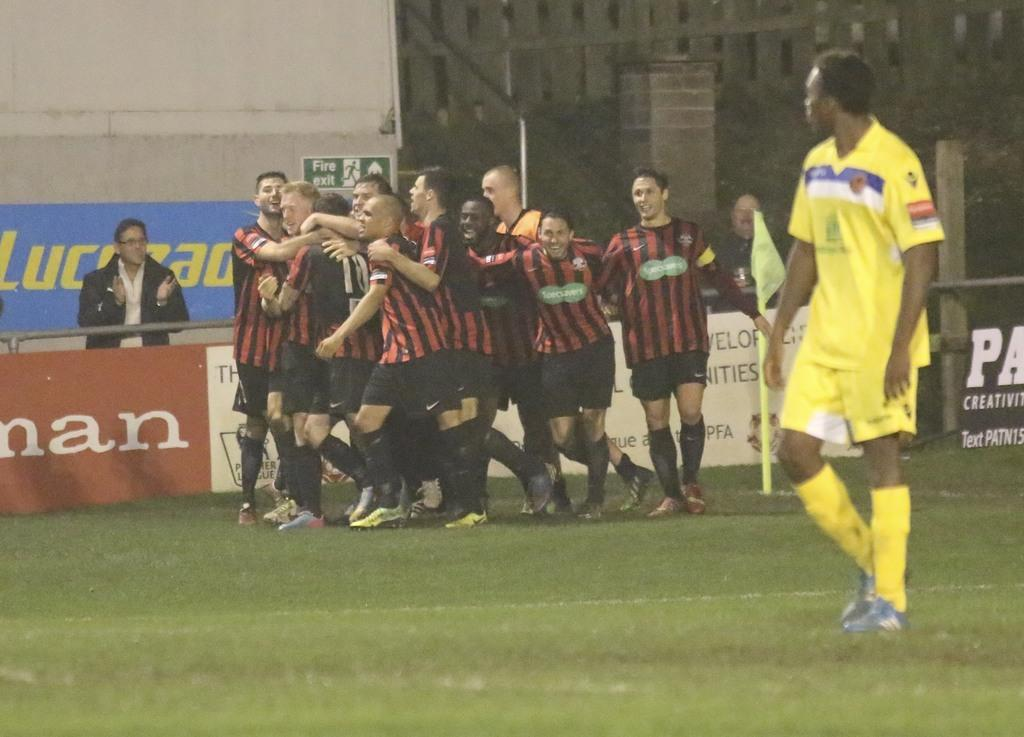<image>
Summarize the visual content of the image. behind the soccer players is the Fire Exit 